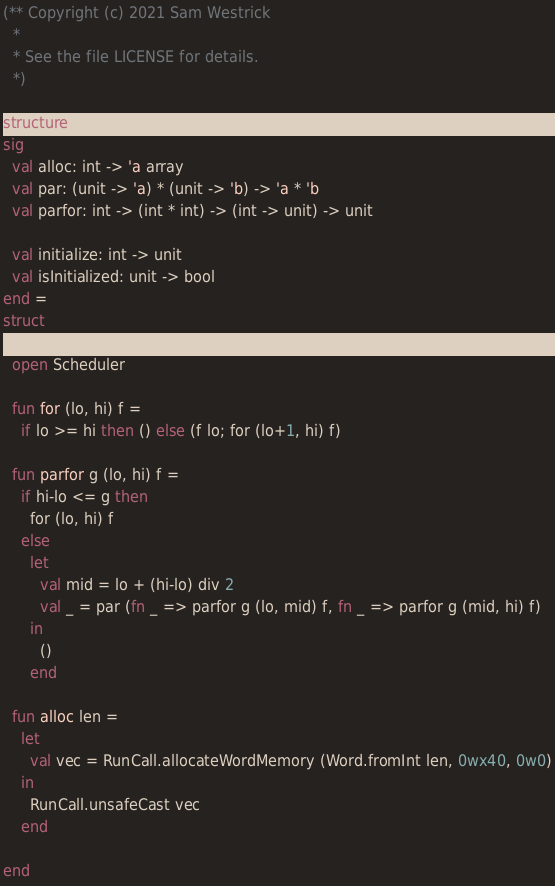Convert code to text. <code><loc_0><loc_0><loc_500><loc_500><_SML_>(** Copyright (c) 2021 Sam Westrick
  *
  * See the file LICENSE for details.
  *)

structure ForkJoin_:
sig
  val alloc: int -> 'a array
  val par: (unit -> 'a) * (unit -> 'b) -> 'a * 'b
  val parfor: int -> (int * int) -> (int -> unit) -> unit

  val initialize: int -> unit
  val isInitialized: unit -> bool
end =
struct

  open Scheduler

  fun for (lo, hi) f =
    if lo >= hi then () else (f lo; for (lo+1, hi) f)

  fun parfor g (lo, hi) f =
    if hi-lo <= g then
      for (lo, hi) f
    else
      let
        val mid = lo + (hi-lo) div 2
        val _ = par (fn _ => parfor g (lo, mid) f, fn _ => parfor g (mid, hi) f)
      in
        ()
      end

  fun alloc len =
    let
      val vec = RunCall.allocateWordMemory (Word.fromInt len, 0wx40, 0w0)
    in
      RunCall.unsafeCast vec
    end

end
</code> 